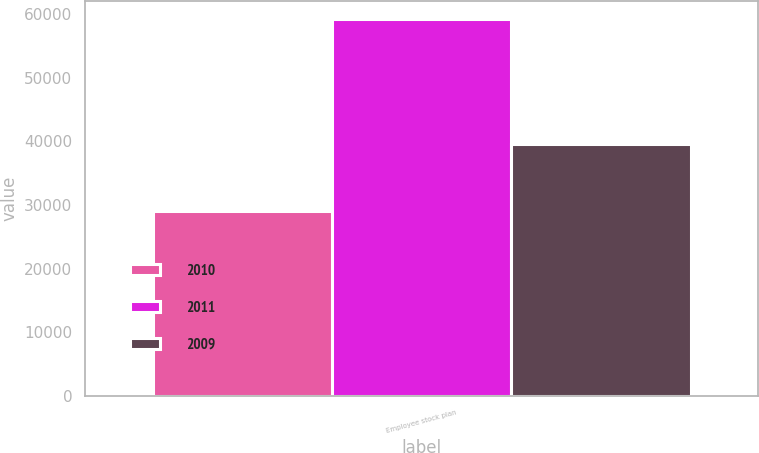Convert chart. <chart><loc_0><loc_0><loc_500><loc_500><stacked_bar_chart><ecel><fcel>Employee stock plan<nl><fcel>2010<fcel>29017<nl><fcel>2011<fcel>59164<nl><fcel>2009<fcel>39537<nl></chart> 